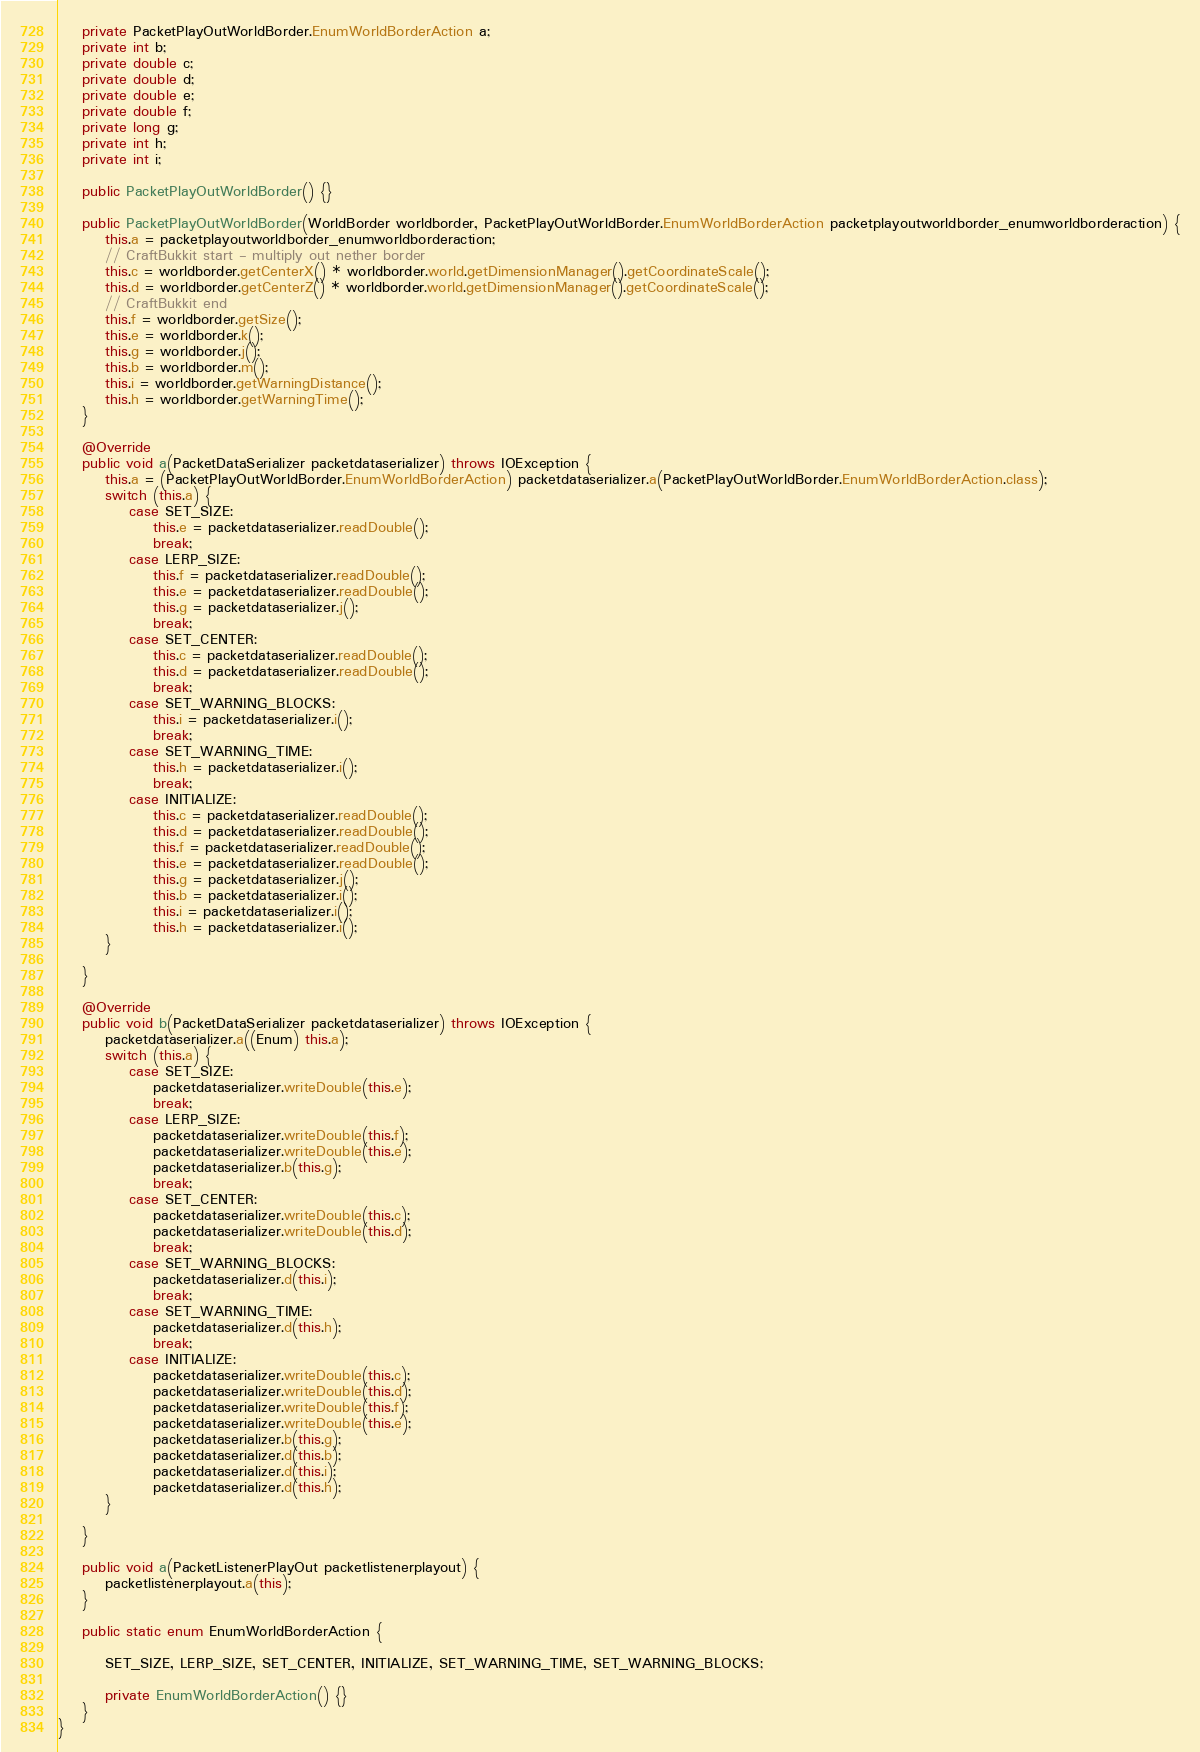<code> <loc_0><loc_0><loc_500><loc_500><_Java_>    private PacketPlayOutWorldBorder.EnumWorldBorderAction a;
    private int b;
    private double c;
    private double d;
    private double e;
    private double f;
    private long g;
    private int h;
    private int i;

    public PacketPlayOutWorldBorder() {}

    public PacketPlayOutWorldBorder(WorldBorder worldborder, PacketPlayOutWorldBorder.EnumWorldBorderAction packetplayoutworldborder_enumworldborderaction) {
        this.a = packetplayoutworldborder_enumworldborderaction;
        // CraftBukkit start - multiply out nether border
        this.c = worldborder.getCenterX() * worldborder.world.getDimensionManager().getCoordinateScale();
        this.d = worldborder.getCenterZ() * worldborder.world.getDimensionManager().getCoordinateScale();
        // CraftBukkit end
        this.f = worldborder.getSize();
        this.e = worldborder.k();
        this.g = worldborder.j();
        this.b = worldborder.m();
        this.i = worldborder.getWarningDistance();
        this.h = worldborder.getWarningTime();
    }

    @Override
    public void a(PacketDataSerializer packetdataserializer) throws IOException {
        this.a = (PacketPlayOutWorldBorder.EnumWorldBorderAction) packetdataserializer.a(PacketPlayOutWorldBorder.EnumWorldBorderAction.class);
        switch (this.a) {
            case SET_SIZE:
                this.e = packetdataserializer.readDouble();
                break;
            case LERP_SIZE:
                this.f = packetdataserializer.readDouble();
                this.e = packetdataserializer.readDouble();
                this.g = packetdataserializer.j();
                break;
            case SET_CENTER:
                this.c = packetdataserializer.readDouble();
                this.d = packetdataserializer.readDouble();
                break;
            case SET_WARNING_BLOCKS:
                this.i = packetdataserializer.i();
                break;
            case SET_WARNING_TIME:
                this.h = packetdataserializer.i();
                break;
            case INITIALIZE:
                this.c = packetdataserializer.readDouble();
                this.d = packetdataserializer.readDouble();
                this.f = packetdataserializer.readDouble();
                this.e = packetdataserializer.readDouble();
                this.g = packetdataserializer.j();
                this.b = packetdataserializer.i();
                this.i = packetdataserializer.i();
                this.h = packetdataserializer.i();
        }

    }

    @Override
    public void b(PacketDataSerializer packetdataserializer) throws IOException {
        packetdataserializer.a((Enum) this.a);
        switch (this.a) {
            case SET_SIZE:
                packetdataserializer.writeDouble(this.e);
                break;
            case LERP_SIZE:
                packetdataserializer.writeDouble(this.f);
                packetdataserializer.writeDouble(this.e);
                packetdataserializer.b(this.g);
                break;
            case SET_CENTER:
                packetdataserializer.writeDouble(this.c);
                packetdataserializer.writeDouble(this.d);
                break;
            case SET_WARNING_BLOCKS:
                packetdataserializer.d(this.i);
                break;
            case SET_WARNING_TIME:
                packetdataserializer.d(this.h);
                break;
            case INITIALIZE:
                packetdataserializer.writeDouble(this.c);
                packetdataserializer.writeDouble(this.d);
                packetdataserializer.writeDouble(this.f);
                packetdataserializer.writeDouble(this.e);
                packetdataserializer.b(this.g);
                packetdataserializer.d(this.b);
                packetdataserializer.d(this.i);
                packetdataserializer.d(this.h);
        }

    }

    public void a(PacketListenerPlayOut packetlistenerplayout) {
        packetlistenerplayout.a(this);
    }

    public static enum EnumWorldBorderAction {

        SET_SIZE, LERP_SIZE, SET_CENTER, INITIALIZE, SET_WARNING_TIME, SET_WARNING_BLOCKS;

        private EnumWorldBorderAction() {}
    }
}
</code> 